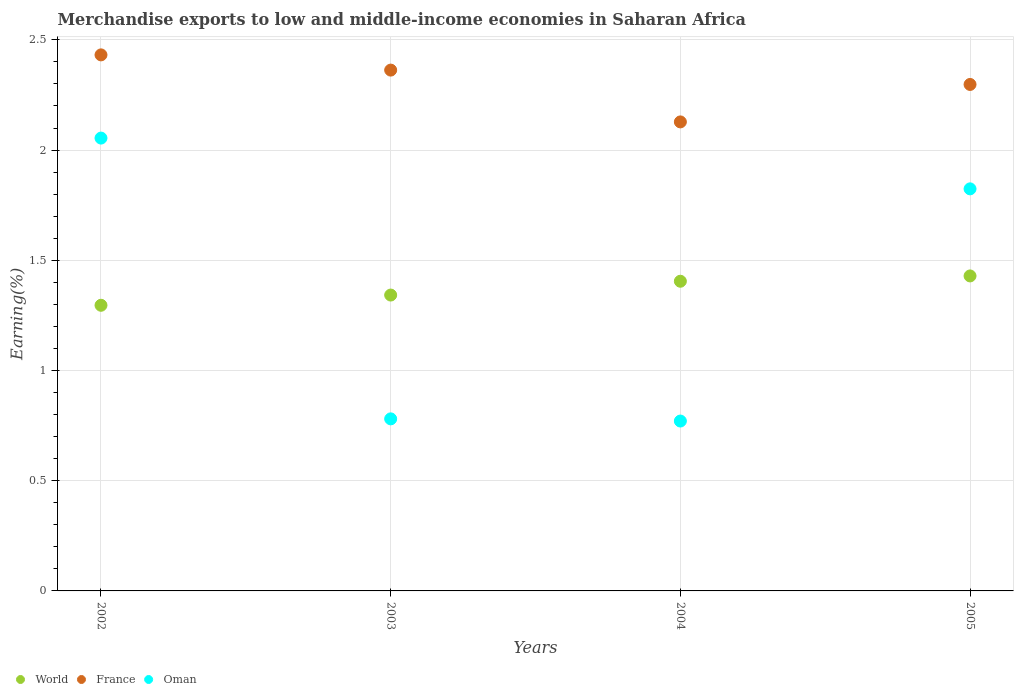What is the percentage of amount earned from merchandise exports in World in 2004?
Your answer should be very brief. 1.4. Across all years, what is the maximum percentage of amount earned from merchandise exports in France?
Give a very brief answer. 2.43. Across all years, what is the minimum percentage of amount earned from merchandise exports in France?
Your answer should be very brief. 2.13. In which year was the percentage of amount earned from merchandise exports in World maximum?
Ensure brevity in your answer.  2005. In which year was the percentage of amount earned from merchandise exports in France minimum?
Keep it short and to the point. 2004. What is the total percentage of amount earned from merchandise exports in Oman in the graph?
Ensure brevity in your answer.  5.43. What is the difference between the percentage of amount earned from merchandise exports in Oman in 2002 and that in 2003?
Give a very brief answer. 1.27. What is the difference between the percentage of amount earned from merchandise exports in France in 2004 and the percentage of amount earned from merchandise exports in Oman in 2005?
Provide a succinct answer. 0.3. What is the average percentage of amount earned from merchandise exports in France per year?
Give a very brief answer. 2.3. In the year 2005, what is the difference between the percentage of amount earned from merchandise exports in France and percentage of amount earned from merchandise exports in Oman?
Make the answer very short. 0.47. In how many years, is the percentage of amount earned from merchandise exports in World greater than 0.9 %?
Your answer should be very brief. 4. What is the ratio of the percentage of amount earned from merchandise exports in Oman in 2002 to that in 2003?
Provide a short and direct response. 2.63. Is the percentage of amount earned from merchandise exports in Oman in 2004 less than that in 2005?
Provide a succinct answer. Yes. What is the difference between the highest and the second highest percentage of amount earned from merchandise exports in Oman?
Give a very brief answer. 0.23. What is the difference between the highest and the lowest percentage of amount earned from merchandise exports in France?
Provide a short and direct response. 0.3. In how many years, is the percentage of amount earned from merchandise exports in France greater than the average percentage of amount earned from merchandise exports in France taken over all years?
Give a very brief answer. 2. Is it the case that in every year, the sum of the percentage of amount earned from merchandise exports in France and percentage of amount earned from merchandise exports in World  is greater than the percentage of amount earned from merchandise exports in Oman?
Provide a short and direct response. Yes. Is the percentage of amount earned from merchandise exports in France strictly less than the percentage of amount earned from merchandise exports in World over the years?
Give a very brief answer. No. How many dotlines are there?
Give a very brief answer. 3. How many years are there in the graph?
Your answer should be very brief. 4. Are the values on the major ticks of Y-axis written in scientific E-notation?
Make the answer very short. No. Where does the legend appear in the graph?
Keep it short and to the point. Bottom left. How many legend labels are there?
Provide a succinct answer. 3. What is the title of the graph?
Your answer should be very brief. Merchandise exports to low and middle-income economies in Saharan Africa. Does "Tunisia" appear as one of the legend labels in the graph?
Give a very brief answer. No. What is the label or title of the Y-axis?
Make the answer very short. Earning(%). What is the Earning(%) in World in 2002?
Keep it short and to the point. 1.3. What is the Earning(%) of France in 2002?
Provide a short and direct response. 2.43. What is the Earning(%) in Oman in 2002?
Your response must be concise. 2.05. What is the Earning(%) in World in 2003?
Provide a short and direct response. 1.34. What is the Earning(%) of France in 2003?
Provide a short and direct response. 2.36. What is the Earning(%) of Oman in 2003?
Provide a succinct answer. 0.78. What is the Earning(%) in World in 2004?
Offer a very short reply. 1.4. What is the Earning(%) of France in 2004?
Make the answer very short. 2.13. What is the Earning(%) of Oman in 2004?
Offer a terse response. 0.77. What is the Earning(%) of World in 2005?
Your answer should be compact. 1.43. What is the Earning(%) of France in 2005?
Provide a succinct answer. 2.3. What is the Earning(%) of Oman in 2005?
Give a very brief answer. 1.82. Across all years, what is the maximum Earning(%) in World?
Provide a succinct answer. 1.43. Across all years, what is the maximum Earning(%) in France?
Give a very brief answer. 2.43. Across all years, what is the maximum Earning(%) in Oman?
Provide a short and direct response. 2.05. Across all years, what is the minimum Earning(%) in World?
Offer a very short reply. 1.3. Across all years, what is the minimum Earning(%) of France?
Give a very brief answer. 2.13. Across all years, what is the minimum Earning(%) in Oman?
Your response must be concise. 0.77. What is the total Earning(%) of World in the graph?
Your answer should be compact. 5.47. What is the total Earning(%) of France in the graph?
Keep it short and to the point. 9.22. What is the total Earning(%) in Oman in the graph?
Make the answer very short. 5.43. What is the difference between the Earning(%) in World in 2002 and that in 2003?
Your answer should be very brief. -0.05. What is the difference between the Earning(%) of France in 2002 and that in 2003?
Give a very brief answer. 0.07. What is the difference between the Earning(%) of Oman in 2002 and that in 2003?
Offer a terse response. 1.27. What is the difference between the Earning(%) of World in 2002 and that in 2004?
Ensure brevity in your answer.  -0.11. What is the difference between the Earning(%) in France in 2002 and that in 2004?
Ensure brevity in your answer.  0.3. What is the difference between the Earning(%) in Oman in 2002 and that in 2004?
Provide a short and direct response. 1.28. What is the difference between the Earning(%) in World in 2002 and that in 2005?
Give a very brief answer. -0.13. What is the difference between the Earning(%) in France in 2002 and that in 2005?
Your response must be concise. 0.13. What is the difference between the Earning(%) of Oman in 2002 and that in 2005?
Make the answer very short. 0.23. What is the difference between the Earning(%) of World in 2003 and that in 2004?
Provide a short and direct response. -0.06. What is the difference between the Earning(%) in France in 2003 and that in 2004?
Your answer should be compact. 0.23. What is the difference between the Earning(%) in Oman in 2003 and that in 2004?
Ensure brevity in your answer.  0.01. What is the difference between the Earning(%) of World in 2003 and that in 2005?
Give a very brief answer. -0.09. What is the difference between the Earning(%) of France in 2003 and that in 2005?
Your answer should be very brief. 0.07. What is the difference between the Earning(%) of Oman in 2003 and that in 2005?
Keep it short and to the point. -1.04. What is the difference between the Earning(%) in World in 2004 and that in 2005?
Provide a succinct answer. -0.02. What is the difference between the Earning(%) in France in 2004 and that in 2005?
Keep it short and to the point. -0.17. What is the difference between the Earning(%) of Oman in 2004 and that in 2005?
Offer a terse response. -1.05. What is the difference between the Earning(%) of World in 2002 and the Earning(%) of France in 2003?
Your answer should be compact. -1.07. What is the difference between the Earning(%) of World in 2002 and the Earning(%) of Oman in 2003?
Ensure brevity in your answer.  0.52. What is the difference between the Earning(%) in France in 2002 and the Earning(%) in Oman in 2003?
Ensure brevity in your answer.  1.65. What is the difference between the Earning(%) in World in 2002 and the Earning(%) in France in 2004?
Keep it short and to the point. -0.83. What is the difference between the Earning(%) of World in 2002 and the Earning(%) of Oman in 2004?
Keep it short and to the point. 0.53. What is the difference between the Earning(%) in France in 2002 and the Earning(%) in Oman in 2004?
Keep it short and to the point. 1.66. What is the difference between the Earning(%) in World in 2002 and the Earning(%) in France in 2005?
Offer a terse response. -1. What is the difference between the Earning(%) of World in 2002 and the Earning(%) of Oman in 2005?
Provide a short and direct response. -0.53. What is the difference between the Earning(%) of France in 2002 and the Earning(%) of Oman in 2005?
Give a very brief answer. 0.61. What is the difference between the Earning(%) in World in 2003 and the Earning(%) in France in 2004?
Give a very brief answer. -0.79. What is the difference between the Earning(%) of World in 2003 and the Earning(%) of Oman in 2004?
Offer a very short reply. 0.57. What is the difference between the Earning(%) of France in 2003 and the Earning(%) of Oman in 2004?
Make the answer very short. 1.59. What is the difference between the Earning(%) in World in 2003 and the Earning(%) in France in 2005?
Provide a short and direct response. -0.96. What is the difference between the Earning(%) in World in 2003 and the Earning(%) in Oman in 2005?
Your response must be concise. -0.48. What is the difference between the Earning(%) of France in 2003 and the Earning(%) of Oman in 2005?
Offer a very short reply. 0.54. What is the difference between the Earning(%) in World in 2004 and the Earning(%) in France in 2005?
Give a very brief answer. -0.89. What is the difference between the Earning(%) of World in 2004 and the Earning(%) of Oman in 2005?
Ensure brevity in your answer.  -0.42. What is the difference between the Earning(%) of France in 2004 and the Earning(%) of Oman in 2005?
Keep it short and to the point. 0.3. What is the average Earning(%) of World per year?
Ensure brevity in your answer.  1.37. What is the average Earning(%) of France per year?
Keep it short and to the point. 2.31. What is the average Earning(%) in Oman per year?
Offer a very short reply. 1.36. In the year 2002, what is the difference between the Earning(%) in World and Earning(%) in France?
Offer a terse response. -1.14. In the year 2002, what is the difference between the Earning(%) of World and Earning(%) of Oman?
Provide a succinct answer. -0.76. In the year 2002, what is the difference between the Earning(%) in France and Earning(%) in Oman?
Your answer should be very brief. 0.38. In the year 2003, what is the difference between the Earning(%) of World and Earning(%) of France?
Your answer should be compact. -1.02. In the year 2003, what is the difference between the Earning(%) in World and Earning(%) in Oman?
Your response must be concise. 0.56. In the year 2003, what is the difference between the Earning(%) of France and Earning(%) of Oman?
Provide a succinct answer. 1.58. In the year 2004, what is the difference between the Earning(%) in World and Earning(%) in France?
Offer a terse response. -0.72. In the year 2004, what is the difference between the Earning(%) of World and Earning(%) of Oman?
Your answer should be very brief. 0.63. In the year 2004, what is the difference between the Earning(%) of France and Earning(%) of Oman?
Your answer should be very brief. 1.36. In the year 2005, what is the difference between the Earning(%) in World and Earning(%) in France?
Your answer should be very brief. -0.87. In the year 2005, what is the difference between the Earning(%) in World and Earning(%) in Oman?
Your answer should be very brief. -0.4. In the year 2005, what is the difference between the Earning(%) in France and Earning(%) in Oman?
Your answer should be compact. 0.47. What is the ratio of the Earning(%) of World in 2002 to that in 2003?
Provide a succinct answer. 0.97. What is the ratio of the Earning(%) of France in 2002 to that in 2003?
Offer a very short reply. 1.03. What is the ratio of the Earning(%) of Oman in 2002 to that in 2003?
Your response must be concise. 2.63. What is the ratio of the Earning(%) in World in 2002 to that in 2004?
Keep it short and to the point. 0.92. What is the ratio of the Earning(%) of France in 2002 to that in 2004?
Provide a succinct answer. 1.14. What is the ratio of the Earning(%) in Oman in 2002 to that in 2004?
Your answer should be compact. 2.67. What is the ratio of the Earning(%) in World in 2002 to that in 2005?
Your response must be concise. 0.91. What is the ratio of the Earning(%) in France in 2002 to that in 2005?
Your answer should be very brief. 1.06. What is the ratio of the Earning(%) in Oman in 2002 to that in 2005?
Your answer should be very brief. 1.13. What is the ratio of the Earning(%) in World in 2003 to that in 2004?
Make the answer very short. 0.96. What is the ratio of the Earning(%) in France in 2003 to that in 2004?
Provide a short and direct response. 1.11. What is the ratio of the Earning(%) of Oman in 2003 to that in 2004?
Make the answer very short. 1.01. What is the ratio of the Earning(%) in World in 2003 to that in 2005?
Offer a very short reply. 0.94. What is the ratio of the Earning(%) in France in 2003 to that in 2005?
Your answer should be compact. 1.03. What is the ratio of the Earning(%) in Oman in 2003 to that in 2005?
Provide a short and direct response. 0.43. What is the ratio of the Earning(%) in World in 2004 to that in 2005?
Ensure brevity in your answer.  0.98. What is the ratio of the Earning(%) of France in 2004 to that in 2005?
Your answer should be very brief. 0.93. What is the ratio of the Earning(%) of Oman in 2004 to that in 2005?
Keep it short and to the point. 0.42. What is the difference between the highest and the second highest Earning(%) in World?
Give a very brief answer. 0.02. What is the difference between the highest and the second highest Earning(%) of France?
Your answer should be very brief. 0.07. What is the difference between the highest and the second highest Earning(%) of Oman?
Keep it short and to the point. 0.23. What is the difference between the highest and the lowest Earning(%) in World?
Your answer should be compact. 0.13. What is the difference between the highest and the lowest Earning(%) of France?
Provide a short and direct response. 0.3. What is the difference between the highest and the lowest Earning(%) of Oman?
Provide a short and direct response. 1.28. 